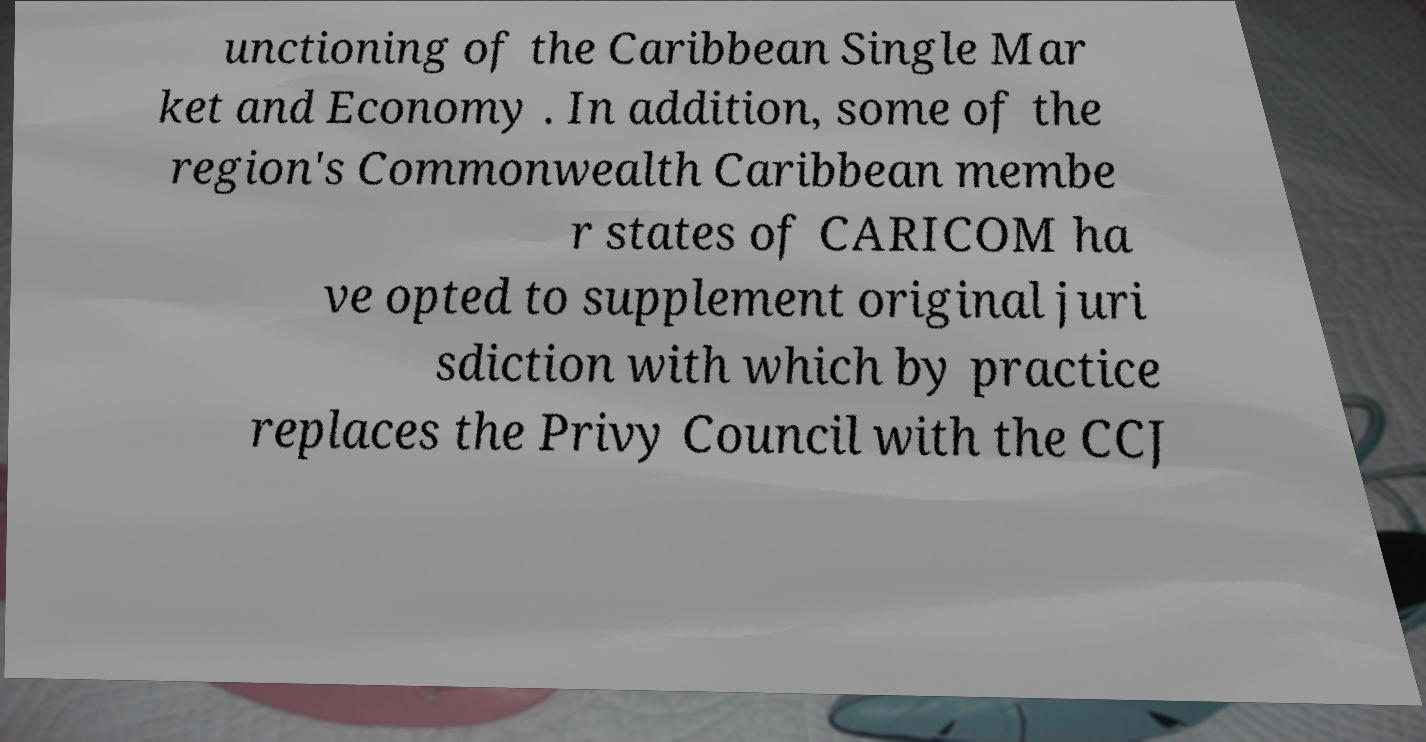Could you assist in decoding the text presented in this image and type it out clearly? unctioning of the Caribbean Single Mar ket and Economy . In addition, some of the region's Commonwealth Caribbean membe r states of CARICOM ha ve opted to supplement original juri sdiction with which by practice replaces the Privy Council with the CCJ 